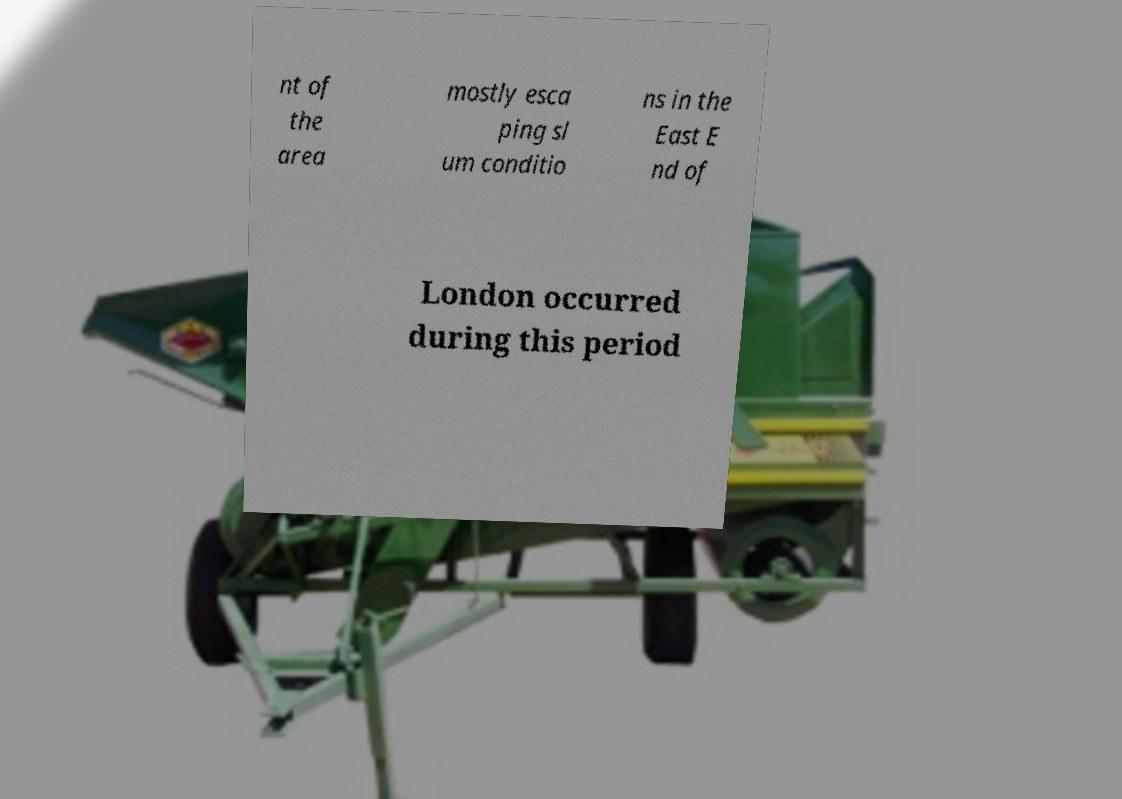What messages or text are displayed in this image? I need them in a readable, typed format. nt of the area mostly esca ping sl um conditio ns in the East E nd of London occurred during this period 